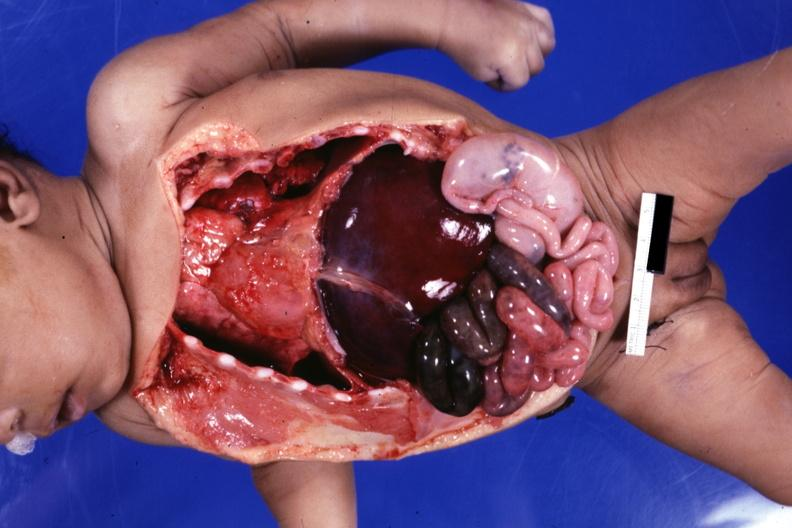what is present?
Answer the question using a single word or phrase. Situs inversus 